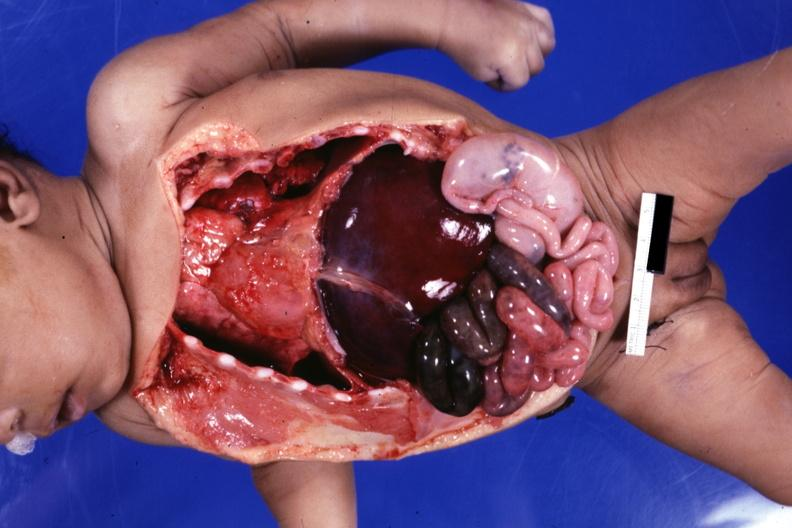what is present?
Answer the question using a single word or phrase. Situs inversus 